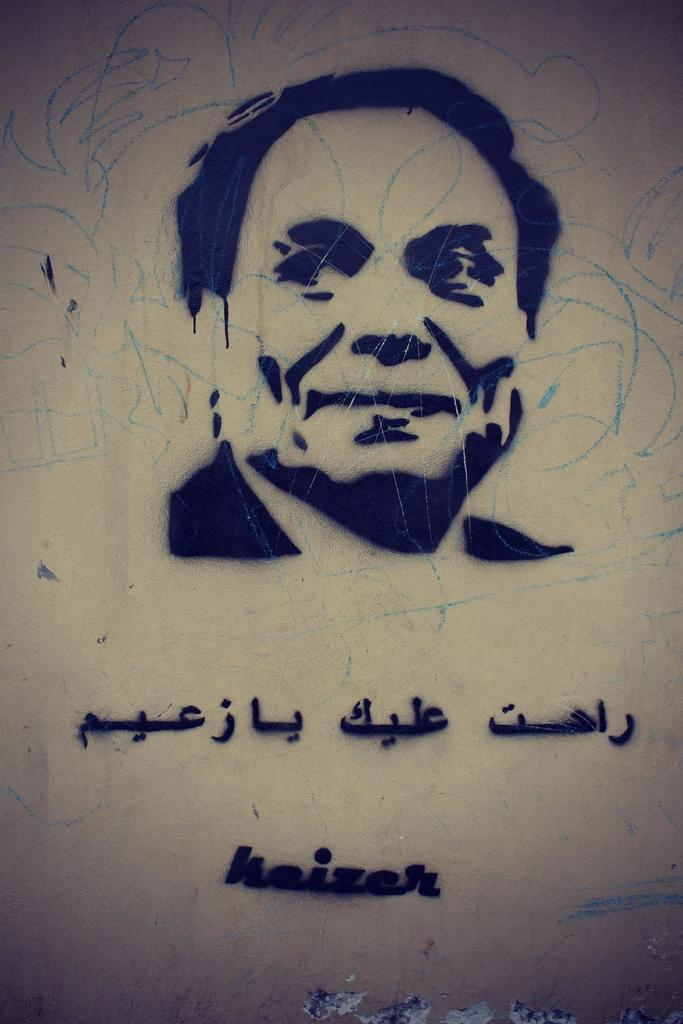What is depicted on the wall in the image? There is a painting of a person on the wall. Are there any additional markings on the wall? Yes, there are scribblings and alphabets in another language on the wall. Can you read any specific words on the wall? There is a word on the wall. What type of punishment is being depicted in the painting on the wall? There is no punishment being depicted in the painting on the wall; it is a painting of a person. 